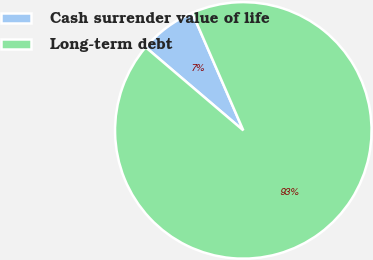Convert chart. <chart><loc_0><loc_0><loc_500><loc_500><pie_chart><fcel>Cash surrender value of life<fcel>Long-term debt<nl><fcel>7.25%<fcel>92.75%<nl></chart> 